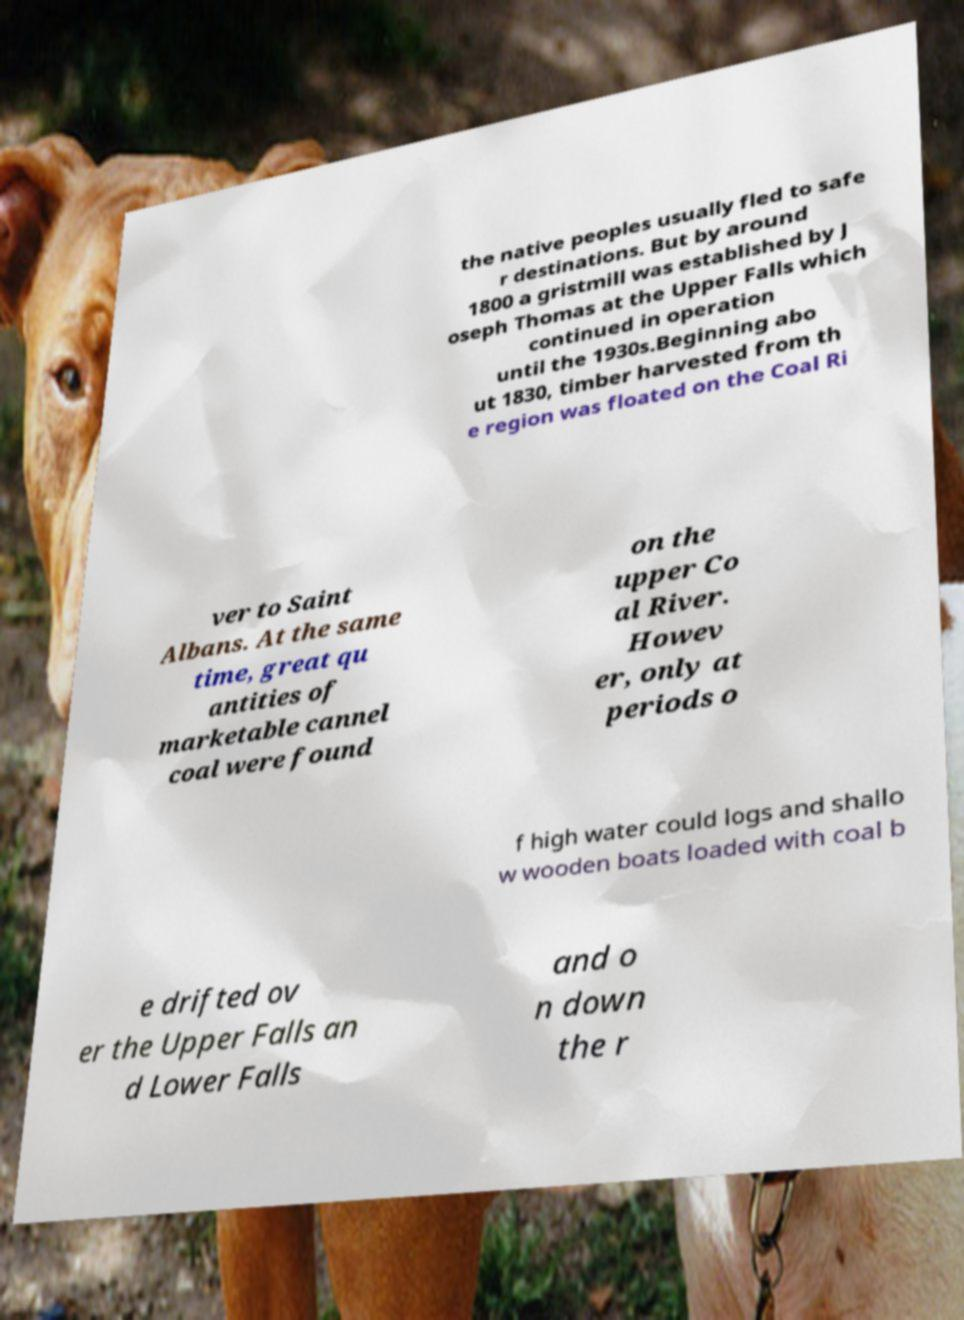Could you extract and type out the text from this image? the native peoples usually fled to safe r destinations. But by around 1800 a gristmill was established by J oseph Thomas at the Upper Falls which continued in operation until the 1930s.Beginning abo ut 1830, timber harvested from th e region was floated on the Coal Ri ver to Saint Albans. At the same time, great qu antities of marketable cannel coal were found on the upper Co al River. Howev er, only at periods o f high water could logs and shallo w wooden boats loaded with coal b e drifted ov er the Upper Falls an d Lower Falls and o n down the r 